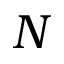<formula> <loc_0><loc_0><loc_500><loc_500>N</formula> 